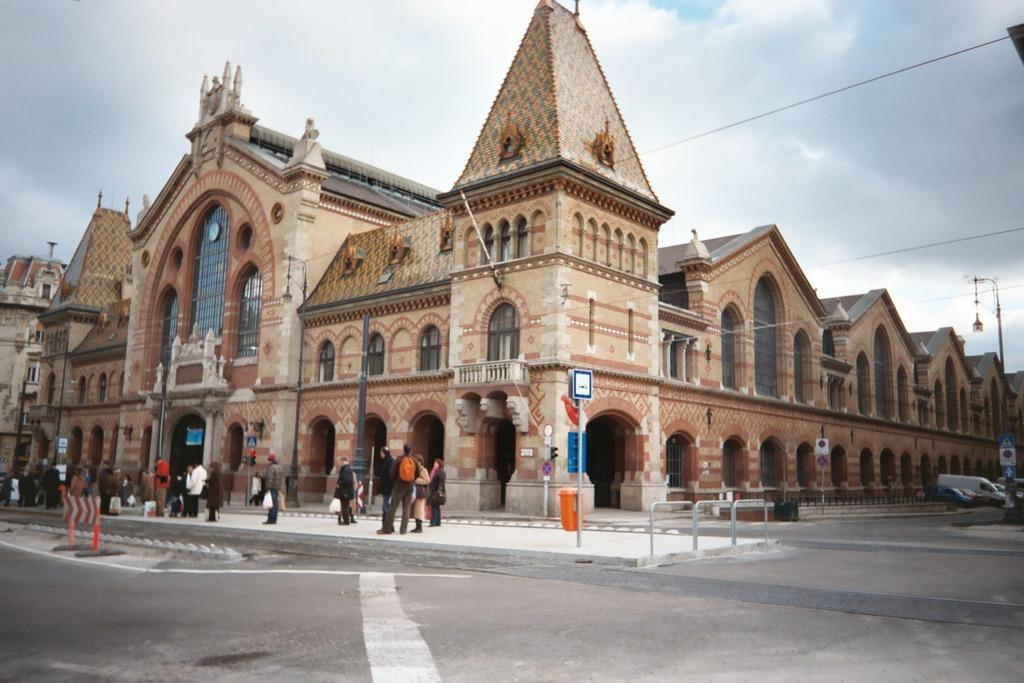What type of structures are visible in the image? There are buildings in the image. What can be seen in front of the buildings? There are people standing in front of the buildings. What else is present in the image besides the buildings and people? There are vehicles on the road in the image. Can you see the ocean in the image? No, the ocean is not present in the image; it features buildings, people, and vehicles. What trick is being performed by the people in the image? There is no trick being performed by the people in the image; they are simply standing in front of the buildings. 